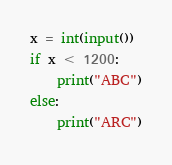<code> <loc_0><loc_0><loc_500><loc_500><_Python_>x = int(input())
if x < 1200:
    print("ABC")
else:
    print("ARC")</code> 